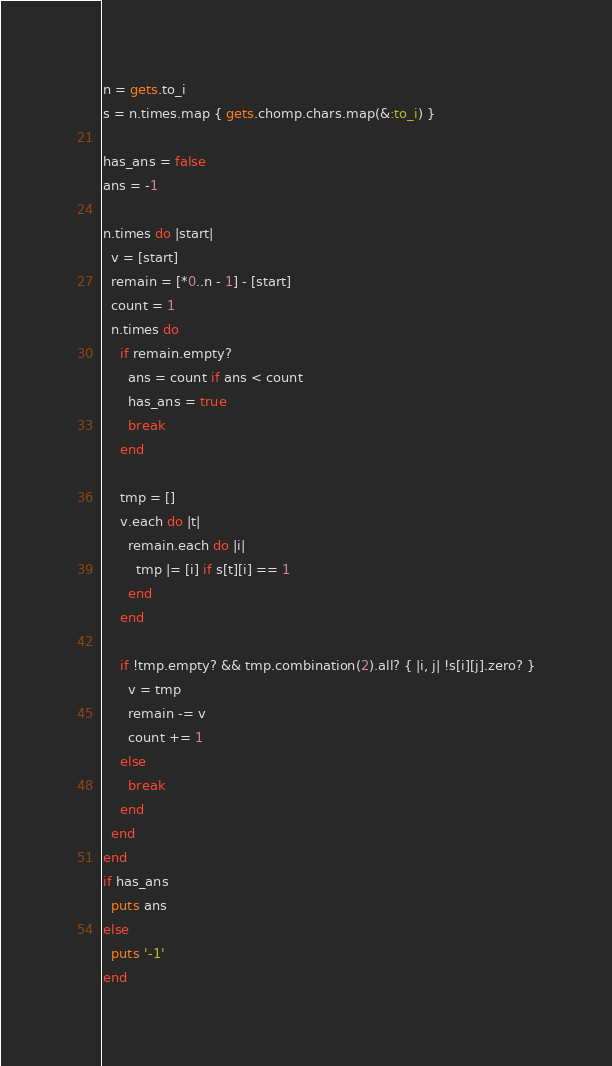Convert code to text. <code><loc_0><loc_0><loc_500><loc_500><_Ruby_>n = gets.to_i
s = n.times.map { gets.chomp.chars.map(&:to_i) }

has_ans = false
ans = -1

n.times do |start|
  v = [start]
  remain = [*0..n - 1] - [start]
  count = 1
  n.times do
    if remain.empty?
      ans = count if ans < count
      has_ans = true
      break
    end

    tmp = []
    v.each do |t|
      remain.each do |i|
        tmp |= [i] if s[t][i] == 1
      end
    end

    if !tmp.empty? && tmp.combination(2).all? { |i, j| !s[i][j].zero? }
      v = tmp
      remain -= v
      count += 1
    else
      break
    end
  end
end
if has_ans
  puts ans
else
  puts '-1'
end</code> 